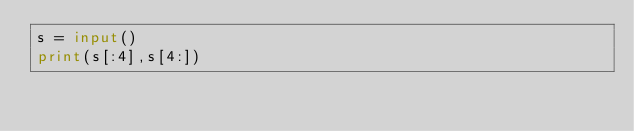Convert code to text. <code><loc_0><loc_0><loc_500><loc_500><_Python_>s = input()
print(s[:4],s[4:])</code> 